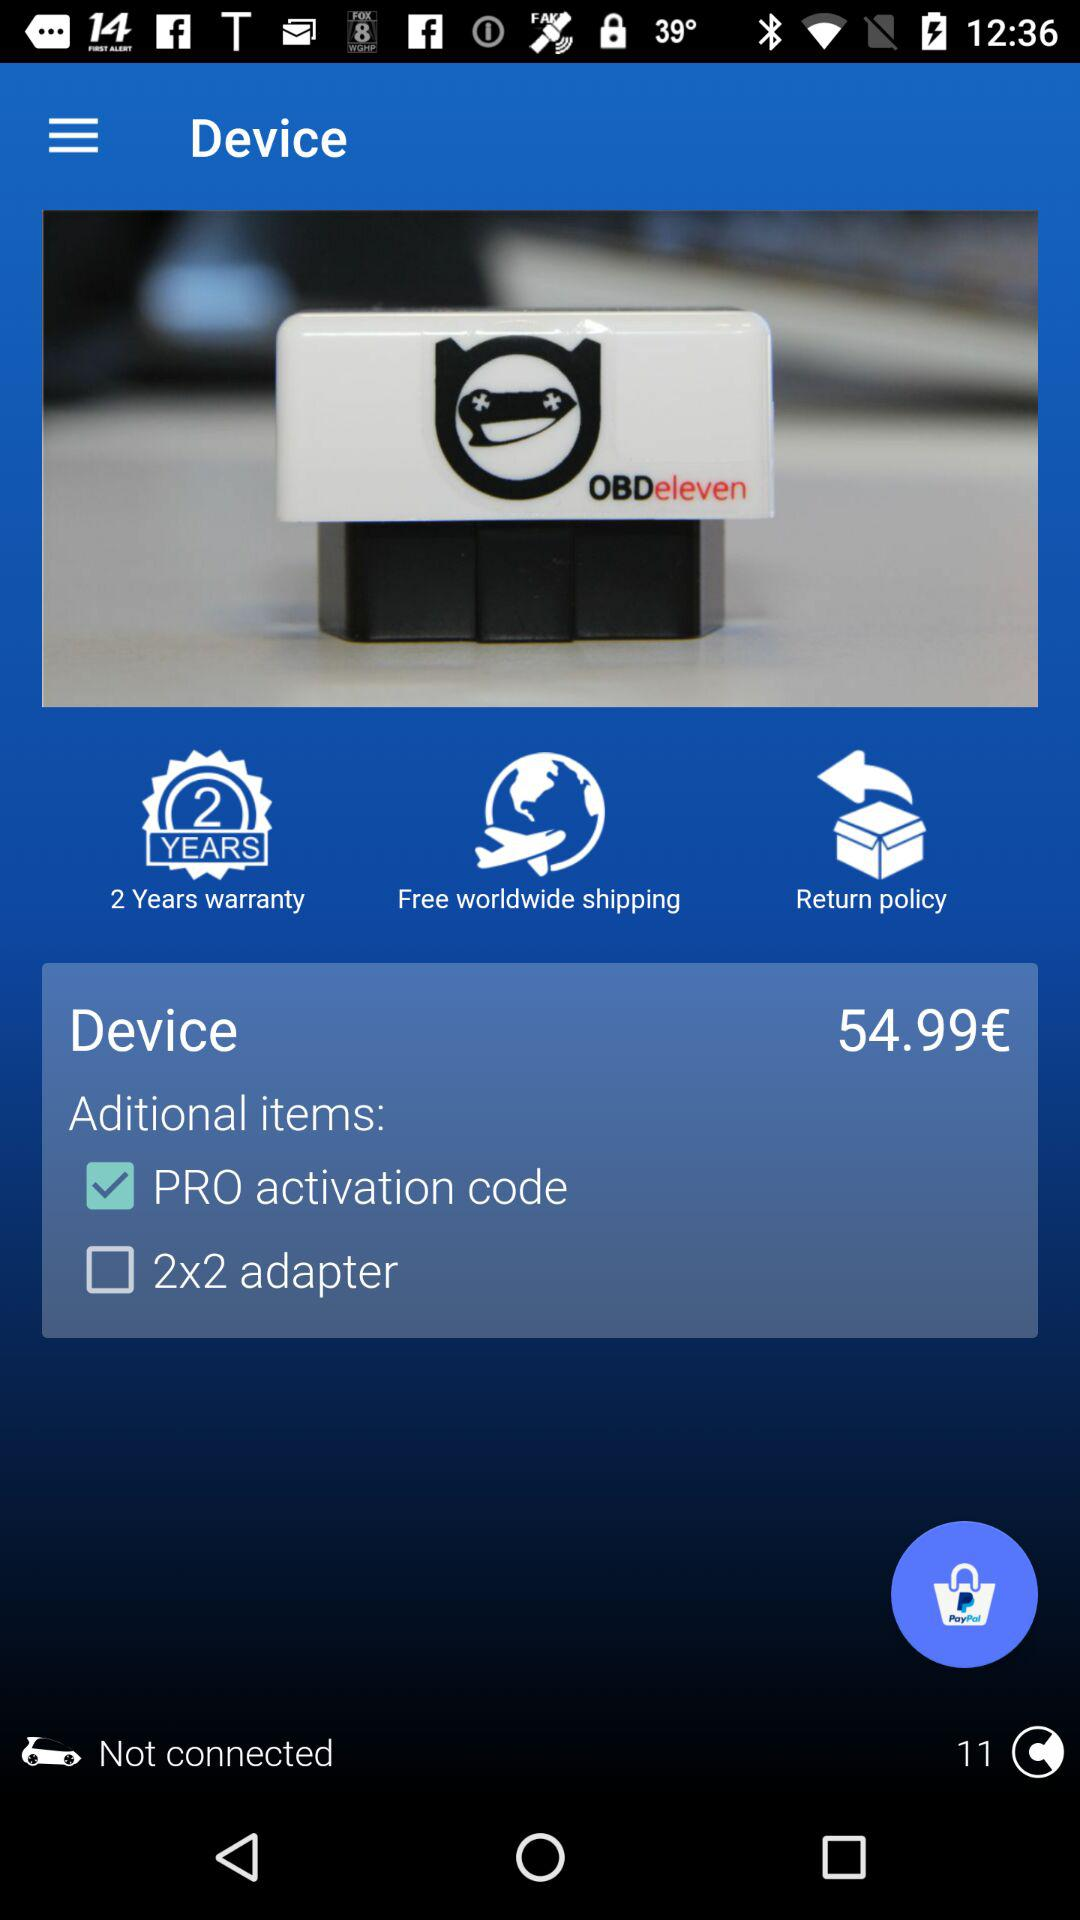Where is the shipment?
When the provided information is insufficient, respond with <no answer>. <no answer> 